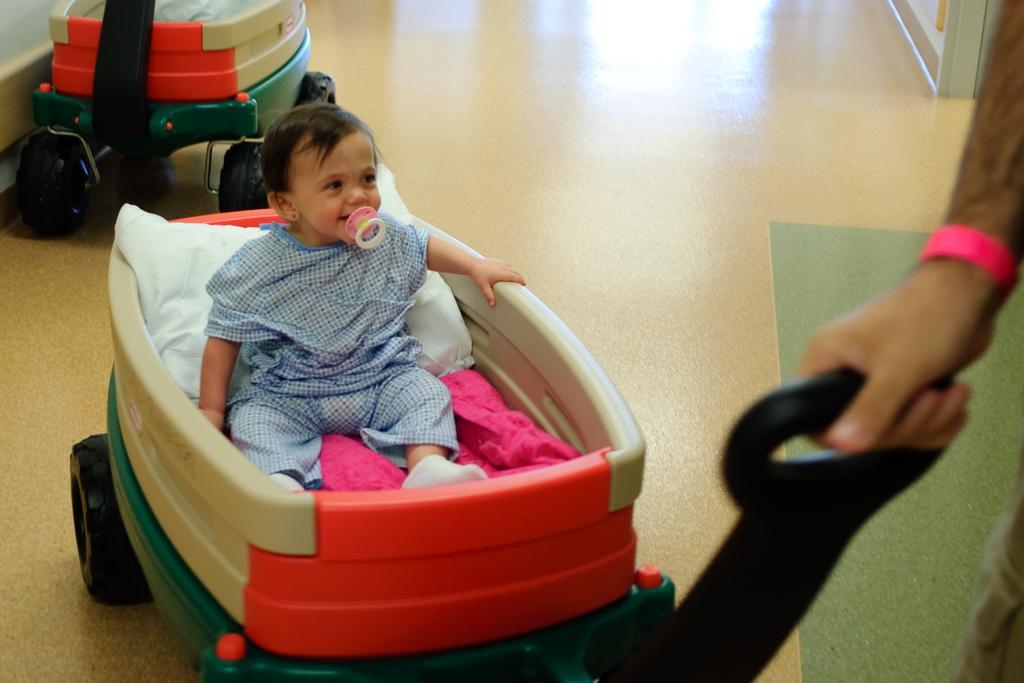Describe this image in one or two sentences. In this image we can see two trolleys, a person holding a trolley and a baby sitting on the trolley with some object in his mouth. 